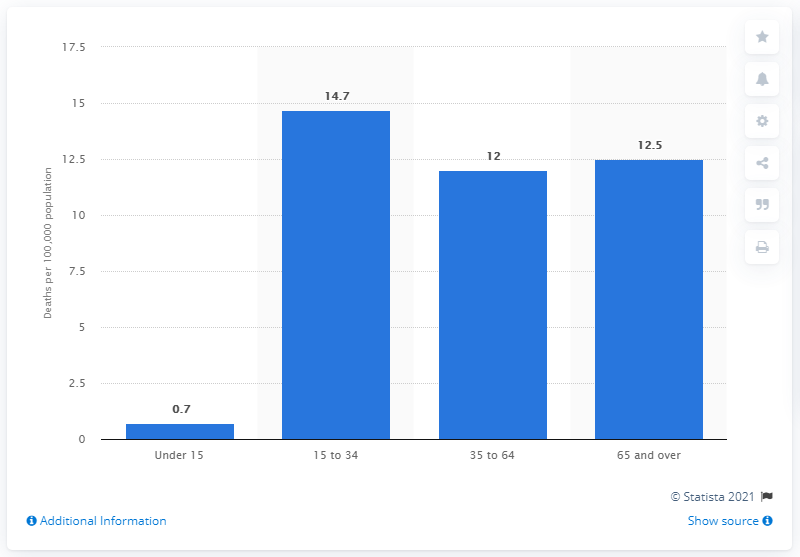Point out several critical features in this image. The average rate of gun deaths among individuals aged 15 to 34 is 14.7 deaths per 100,000 individuals. 